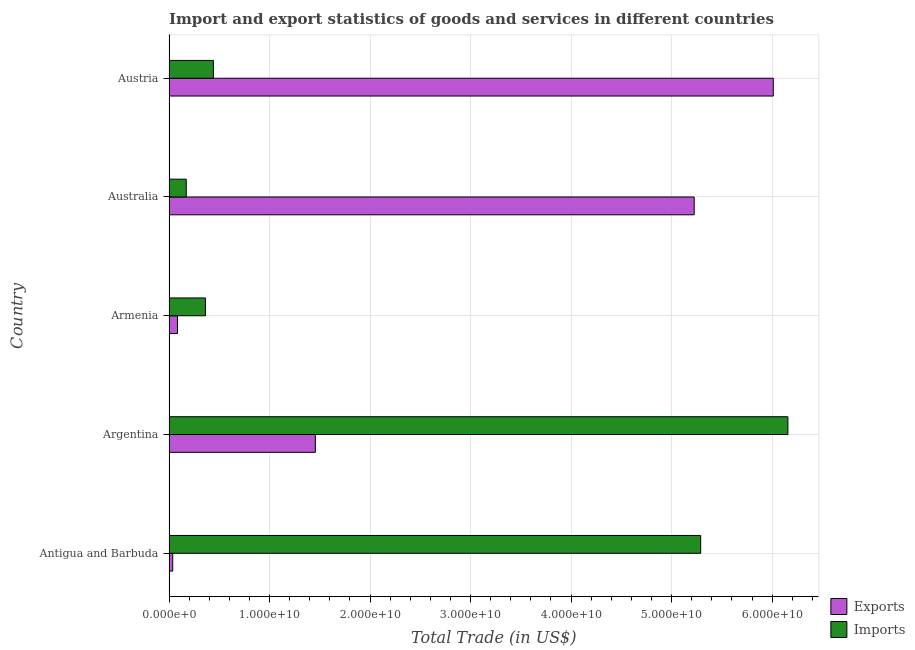Are the number of bars per tick equal to the number of legend labels?
Provide a short and direct response. Yes. Are the number of bars on each tick of the Y-axis equal?
Your response must be concise. Yes. What is the label of the 3rd group of bars from the top?
Keep it short and to the point. Armenia. In how many cases, is the number of bars for a given country not equal to the number of legend labels?
Ensure brevity in your answer.  0. What is the imports of goods and services in Argentina?
Offer a very short reply. 6.16e+1. Across all countries, what is the maximum imports of goods and services?
Offer a very short reply. 6.16e+1. Across all countries, what is the minimum imports of goods and services?
Ensure brevity in your answer.  1.72e+09. In which country was the export of goods and services minimum?
Your answer should be compact. Antigua and Barbuda. What is the total export of goods and services in the graph?
Ensure brevity in your answer.  1.28e+11. What is the difference between the imports of goods and services in Antigua and Barbuda and that in Armenia?
Make the answer very short. 4.93e+1. What is the difference between the imports of goods and services in Austria and the export of goods and services in Antigua and Barbuda?
Provide a short and direct response. 4.05e+09. What is the average export of goods and services per country?
Make the answer very short. 2.56e+1. What is the difference between the export of goods and services and imports of goods and services in Armenia?
Provide a succinct answer. -2.78e+09. What is the ratio of the export of goods and services in Armenia to that in Austria?
Your answer should be compact. 0.01. Is the export of goods and services in Antigua and Barbuda less than that in Armenia?
Make the answer very short. Yes. Is the difference between the imports of goods and services in Argentina and Armenia greater than the difference between the export of goods and services in Argentina and Armenia?
Give a very brief answer. Yes. What is the difference between the highest and the second highest imports of goods and services?
Ensure brevity in your answer.  8.68e+09. What is the difference between the highest and the lowest imports of goods and services?
Provide a succinct answer. 5.99e+1. Is the sum of the export of goods and services in Australia and Austria greater than the maximum imports of goods and services across all countries?
Give a very brief answer. Yes. What does the 1st bar from the top in Antigua and Barbuda represents?
Your answer should be compact. Imports. What does the 2nd bar from the bottom in Australia represents?
Ensure brevity in your answer.  Imports. How many bars are there?
Provide a short and direct response. 10. What is the difference between two consecutive major ticks on the X-axis?
Give a very brief answer. 1.00e+1. Does the graph contain any zero values?
Provide a short and direct response. No. Does the graph contain grids?
Provide a short and direct response. Yes. How many legend labels are there?
Give a very brief answer. 2. How are the legend labels stacked?
Provide a succinct answer. Vertical. What is the title of the graph?
Offer a terse response. Import and export statistics of goods and services in different countries. What is the label or title of the X-axis?
Provide a succinct answer. Total Trade (in US$). What is the label or title of the Y-axis?
Your answer should be compact. Country. What is the Total Trade (in US$) in Exports in Antigua and Barbuda?
Your answer should be very brief. 3.70e+08. What is the Total Trade (in US$) in Imports in Antigua and Barbuda?
Offer a terse response. 5.29e+1. What is the Total Trade (in US$) in Exports in Argentina?
Provide a succinct answer. 1.46e+1. What is the Total Trade (in US$) of Imports in Argentina?
Offer a terse response. 6.16e+1. What is the Total Trade (in US$) in Exports in Armenia?
Give a very brief answer. 8.43e+08. What is the Total Trade (in US$) in Imports in Armenia?
Give a very brief answer. 3.62e+09. What is the Total Trade (in US$) of Exports in Australia?
Offer a terse response. 5.22e+1. What is the Total Trade (in US$) in Imports in Australia?
Offer a terse response. 1.72e+09. What is the Total Trade (in US$) in Exports in Austria?
Ensure brevity in your answer.  6.01e+1. What is the Total Trade (in US$) in Imports in Austria?
Ensure brevity in your answer.  4.41e+09. Across all countries, what is the maximum Total Trade (in US$) in Exports?
Provide a succinct answer. 6.01e+1. Across all countries, what is the maximum Total Trade (in US$) of Imports?
Your response must be concise. 6.16e+1. Across all countries, what is the minimum Total Trade (in US$) in Exports?
Your answer should be compact. 3.70e+08. Across all countries, what is the minimum Total Trade (in US$) in Imports?
Keep it short and to the point. 1.72e+09. What is the total Total Trade (in US$) in Exports in the graph?
Your answer should be compact. 1.28e+11. What is the total Total Trade (in US$) of Imports in the graph?
Make the answer very short. 1.24e+11. What is the difference between the Total Trade (in US$) of Exports in Antigua and Barbuda and that in Argentina?
Make the answer very short. -1.42e+1. What is the difference between the Total Trade (in US$) in Imports in Antigua and Barbuda and that in Argentina?
Give a very brief answer. -8.68e+09. What is the difference between the Total Trade (in US$) of Exports in Antigua and Barbuda and that in Armenia?
Your answer should be very brief. -4.73e+08. What is the difference between the Total Trade (in US$) of Imports in Antigua and Barbuda and that in Armenia?
Offer a terse response. 4.93e+1. What is the difference between the Total Trade (in US$) of Exports in Antigua and Barbuda and that in Australia?
Your answer should be compact. -5.19e+1. What is the difference between the Total Trade (in US$) in Imports in Antigua and Barbuda and that in Australia?
Provide a succinct answer. 5.12e+1. What is the difference between the Total Trade (in US$) of Exports in Antigua and Barbuda and that in Austria?
Keep it short and to the point. -5.97e+1. What is the difference between the Total Trade (in US$) of Imports in Antigua and Barbuda and that in Austria?
Provide a short and direct response. 4.85e+1. What is the difference between the Total Trade (in US$) of Exports in Argentina and that in Armenia?
Give a very brief answer. 1.37e+1. What is the difference between the Total Trade (in US$) in Imports in Argentina and that in Armenia?
Make the answer very short. 5.79e+1. What is the difference between the Total Trade (in US$) of Exports in Argentina and that in Australia?
Offer a very short reply. -3.77e+1. What is the difference between the Total Trade (in US$) in Imports in Argentina and that in Australia?
Make the answer very short. 5.99e+1. What is the difference between the Total Trade (in US$) of Exports in Argentina and that in Austria?
Give a very brief answer. -4.56e+1. What is the difference between the Total Trade (in US$) of Imports in Argentina and that in Austria?
Offer a very short reply. 5.72e+1. What is the difference between the Total Trade (in US$) of Exports in Armenia and that in Australia?
Offer a very short reply. -5.14e+1. What is the difference between the Total Trade (in US$) in Imports in Armenia and that in Australia?
Your answer should be very brief. 1.91e+09. What is the difference between the Total Trade (in US$) in Exports in Armenia and that in Austria?
Offer a very short reply. -5.93e+1. What is the difference between the Total Trade (in US$) in Imports in Armenia and that in Austria?
Your answer should be very brief. -7.92e+08. What is the difference between the Total Trade (in US$) of Exports in Australia and that in Austria?
Your answer should be compact. -7.87e+09. What is the difference between the Total Trade (in US$) in Imports in Australia and that in Austria?
Your answer should be compact. -2.70e+09. What is the difference between the Total Trade (in US$) of Exports in Antigua and Barbuda and the Total Trade (in US$) of Imports in Argentina?
Your answer should be compact. -6.12e+1. What is the difference between the Total Trade (in US$) of Exports in Antigua and Barbuda and the Total Trade (in US$) of Imports in Armenia?
Make the answer very short. -3.25e+09. What is the difference between the Total Trade (in US$) in Exports in Antigua and Barbuda and the Total Trade (in US$) in Imports in Australia?
Keep it short and to the point. -1.35e+09. What is the difference between the Total Trade (in US$) in Exports in Antigua and Barbuda and the Total Trade (in US$) in Imports in Austria?
Make the answer very short. -4.05e+09. What is the difference between the Total Trade (in US$) in Exports in Argentina and the Total Trade (in US$) in Imports in Armenia?
Provide a short and direct response. 1.09e+1. What is the difference between the Total Trade (in US$) of Exports in Argentina and the Total Trade (in US$) of Imports in Australia?
Provide a succinct answer. 1.28e+1. What is the difference between the Total Trade (in US$) in Exports in Argentina and the Total Trade (in US$) in Imports in Austria?
Ensure brevity in your answer.  1.01e+1. What is the difference between the Total Trade (in US$) in Exports in Armenia and the Total Trade (in US$) in Imports in Australia?
Your answer should be compact. -8.74e+08. What is the difference between the Total Trade (in US$) of Exports in Armenia and the Total Trade (in US$) of Imports in Austria?
Keep it short and to the point. -3.57e+09. What is the difference between the Total Trade (in US$) in Exports in Australia and the Total Trade (in US$) in Imports in Austria?
Keep it short and to the point. 4.78e+1. What is the average Total Trade (in US$) of Exports per country?
Keep it short and to the point. 2.56e+1. What is the average Total Trade (in US$) of Imports per country?
Offer a very short reply. 2.48e+1. What is the difference between the Total Trade (in US$) of Exports and Total Trade (in US$) of Imports in Antigua and Barbuda?
Give a very brief answer. -5.25e+1. What is the difference between the Total Trade (in US$) in Exports and Total Trade (in US$) in Imports in Argentina?
Your answer should be compact. -4.70e+1. What is the difference between the Total Trade (in US$) of Exports and Total Trade (in US$) of Imports in Armenia?
Offer a terse response. -2.78e+09. What is the difference between the Total Trade (in US$) in Exports and Total Trade (in US$) in Imports in Australia?
Ensure brevity in your answer.  5.05e+1. What is the difference between the Total Trade (in US$) of Exports and Total Trade (in US$) of Imports in Austria?
Your response must be concise. 5.57e+1. What is the ratio of the Total Trade (in US$) in Exports in Antigua and Barbuda to that in Argentina?
Offer a very short reply. 0.03. What is the ratio of the Total Trade (in US$) of Imports in Antigua and Barbuda to that in Argentina?
Give a very brief answer. 0.86. What is the ratio of the Total Trade (in US$) of Exports in Antigua and Barbuda to that in Armenia?
Provide a short and direct response. 0.44. What is the ratio of the Total Trade (in US$) in Imports in Antigua and Barbuda to that in Armenia?
Your answer should be compact. 14.6. What is the ratio of the Total Trade (in US$) of Exports in Antigua and Barbuda to that in Australia?
Ensure brevity in your answer.  0.01. What is the ratio of the Total Trade (in US$) of Imports in Antigua and Barbuda to that in Australia?
Ensure brevity in your answer.  30.82. What is the ratio of the Total Trade (in US$) of Exports in Antigua and Barbuda to that in Austria?
Your response must be concise. 0.01. What is the ratio of the Total Trade (in US$) in Imports in Antigua and Barbuda to that in Austria?
Provide a succinct answer. 11.98. What is the ratio of the Total Trade (in US$) in Exports in Argentina to that in Armenia?
Make the answer very short. 17.28. What is the ratio of the Total Trade (in US$) in Imports in Argentina to that in Armenia?
Provide a short and direct response. 17. What is the ratio of the Total Trade (in US$) in Exports in Argentina to that in Australia?
Make the answer very short. 0.28. What is the ratio of the Total Trade (in US$) in Imports in Argentina to that in Australia?
Ensure brevity in your answer.  35.87. What is the ratio of the Total Trade (in US$) of Exports in Argentina to that in Austria?
Offer a very short reply. 0.24. What is the ratio of the Total Trade (in US$) in Imports in Argentina to that in Austria?
Keep it short and to the point. 13.95. What is the ratio of the Total Trade (in US$) of Exports in Armenia to that in Australia?
Keep it short and to the point. 0.02. What is the ratio of the Total Trade (in US$) of Imports in Armenia to that in Australia?
Your response must be concise. 2.11. What is the ratio of the Total Trade (in US$) of Exports in Armenia to that in Austria?
Your response must be concise. 0.01. What is the ratio of the Total Trade (in US$) in Imports in Armenia to that in Austria?
Keep it short and to the point. 0.82. What is the ratio of the Total Trade (in US$) of Exports in Australia to that in Austria?
Give a very brief answer. 0.87. What is the ratio of the Total Trade (in US$) in Imports in Australia to that in Austria?
Provide a succinct answer. 0.39. What is the difference between the highest and the second highest Total Trade (in US$) in Exports?
Your answer should be compact. 7.87e+09. What is the difference between the highest and the second highest Total Trade (in US$) of Imports?
Provide a succinct answer. 8.68e+09. What is the difference between the highest and the lowest Total Trade (in US$) of Exports?
Provide a short and direct response. 5.97e+1. What is the difference between the highest and the lowest Total Trade (in US$) in Imports?
Your answer should be compact. 5.99e+1. 